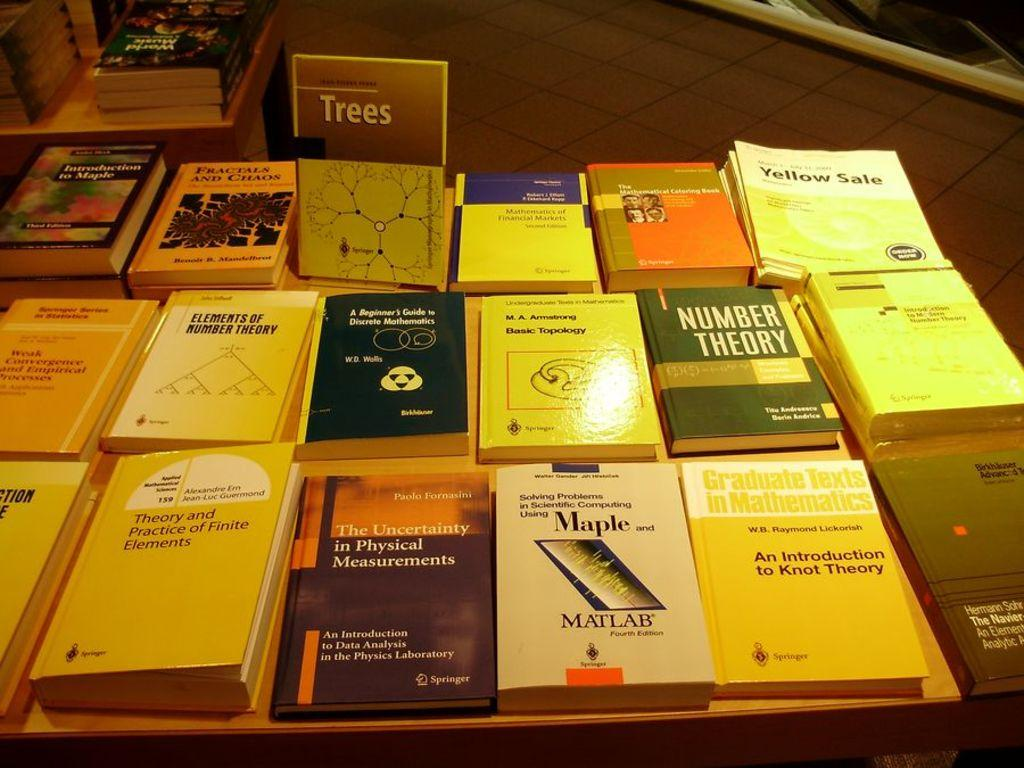<image>
Relay a brief, clear account of the picture shown. Many mathematics books are among the literature on the table. 